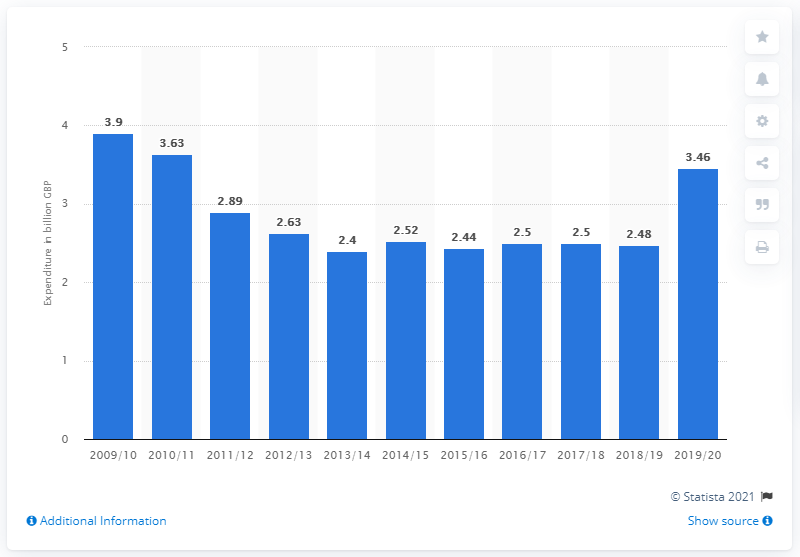Identify some key points in this picture. The government spent 3.9 billion on public transport in 2009/10. In 2010/11, the expenditure on public transport was 3.63.. 